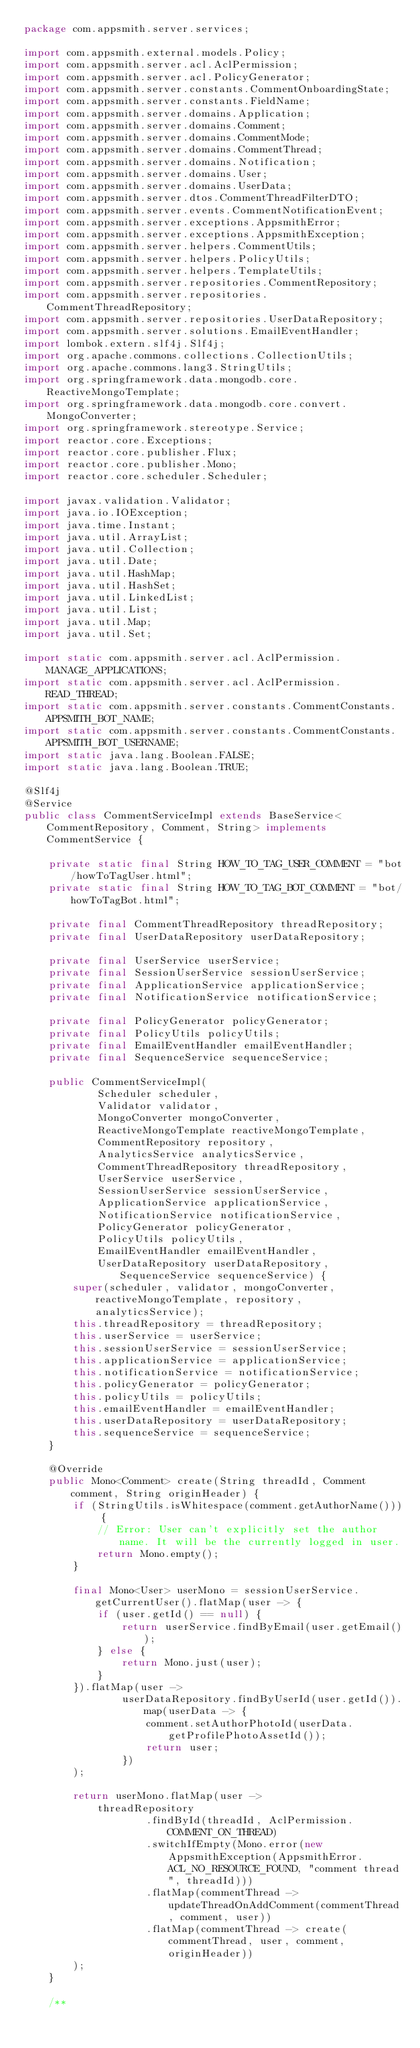Convert code to text. <code><loc_0><loc_0><loc_500><loc_500><_Java_>package com.appsmith.server.services;

import com.appsmith.external.models.Policy;
import com.appsmith.server.acl.AclPermission;
import com.appsmith.server.acl.PolicyGenerator;
import com.appsmith.server.constants.CommentOnboardingState;
import com.appsmith.server.constants.FieldName;
import com.appsmith.server.domains.Application;
import com.appsmith.server.domains.Comment;
import com.appsmith.server.domains.CommentMode;
import com.appsmith.server.domains.CommentThread;
import com.appsmith.server.domains.Notification;
import com.appsmith.server.domains.User;
import com.appsmith.server.domains.UserData;
import com.appsmith.server.dtos.CommentThreadFilterDTO;
import com.appsmith.server.events.CommentNotificationEvent;
import com.appsmith.server.exceptions.AppsmithError;
import com.appsmith.server.exceptions.AppsmithException;
import com.appsmith.server.helpers.CommentUtils;
import com.appsmith.server.helpers.PolicyUtils;
import com.appsmith.server.helpers.TemplateUtils;
import com.appsmith.server.repositories.CommentRepository;
import com.appsmith.server.repositories.CommentThreadRepository;
import com.appsmith.server.repositories.UserDataRepository;
import com.appsmith.server.solutions.EmailEventHandler;
import lombok.extern.slf4j.Slf4j;
import org.apache.commons.collections.CollectionUtils;
import org.apache.commons.lang3.StringUtils;
import org.springframework.data.mongodb.core.ReactiveMongoTemplate;
import org.springframework.data.mongodb.core.convert.MongoConverter;
import org.springframework.stereotype.Service;
import reactor.core.Exceptions;
import reactor.core.publisher.Flux;
import reactor.core.publisher.Mono;
import reactor.core.scheduler.Scheduler;

import javax.validation.Validator;
import java.io.IOException;
import java.time.Instant;
import java.util.ArrayList;
import java.util.Collection;
import java.util.Date;
import java.util.HashMap;
import java.util.HashSet;
import java.util.LinkedList;
import java.util.List;
import java.util.Map;
import java.util.Set;

import static com.appsmith.server.acl.AclPermission.MANAGE_APPLICATIONS;
import static com.appsmith.server.acl.AclPermission.READ_THREAD;
import static com.appsmith.server.constants.CommentConstants.APPSMITH_BOT_NAME;
import static com.appsmith.server.constants.CommentConstants.APPSMITH_BOT_USERNAME;
import static java.lang.Boolean.FALSE;
import static java.lang.Boolean.TRUE;

@Slf4j
@Service
public class CommentServiceImpl extends BaseService<CommentRepository, Comment, String> implements CommentService {

    private static final String HOW_TO_TAG_USER_COMMENT = "bot/howToTagUser.html";
    private static final String HOW_TO_TAG_BOT_COMMENT = "bot/howToTagBot.html";

    private final CommentThreadRepository threadRepository;
    private final UserDataRepository userDataRepository;

    private final UserService userService;
    private final SessionUserService sessionUserService;
    private final ApplicationService applicationService;
    private final NotificationService notificationService;

    private final PolicyGenerator policyGenerator;
    private final PolicyUtils policyUtils;
    private final EmailEventHandler emailEventHandler;
    private final SequenceService sequenceService;

    public CommentServiceImpl(
            Scheduler scheduler,
            Validator validator,
            MongoConverter mongoConverter,
            ReactiveMongoTemplate reactiveMongoTemplate,
            CommentRepository repository,
            AnalyticsService analyticsService,
            CommentThreadRepository threadRepository,
            UserService userService,
            SessionUserService sessionUserService,
            ApplicationService applicationService,
            NotificationService notificationService,
            PolicyGenerator policyGenerator,
            PolicyUtils policyUtils,
            EmailEventHandler emailEventHandler,
            UserDataRepository userDataRepository, SequenceService sequenceService) {
        super(scheduler, validator, mongoConverter, reactiveMongoTemplate, repository, analyticsService);
        this.threadRepository = threadRepository;
        this.userService = userService;
        this.sessionUserService = sessionUserService;
        this.applicationService = applicationService;
        this.notificationService = notificationService;
        this.policyGenerator = policyGenerator;
        this.policyUtils = policyUtils;
        this.emailEventHandler = emailEventHandler;
        this.userDataRepository = userDataRepository;
        this.sequenceService = sequenceService;
    }

    @Override
    public Mono<Comment> create(String threadId, Comment comment, String originHeader) {
        if (StringUtils.isWhitespace(comment.getAuthorName())) {
            // Error: User can't explicitly set the author name. It will be the currently logged in user.
            return Mono.empty();
        }

        final Mono<User> userMono = sessionUserService.getCurrentUser().flatMap(user -> {
            if (user.getId() == null) {
                return userService.findByEmail(user.getEmail());
            } else {
                return Mono.just(user);
            }
        }).flatMap(user ->
                userDataRepository.findByUserId(user.getId()).map(userData -> {
                    comment.setAuthorPhotoId(userData.getProfilePhotoAssetId());
                    return user;
                })
        );

        return userMono.flatMap(user ->
            threadRepository
                    .findById(threadId, AclPermission.COMMENT_ON_THREAD)
                    .switchIfEmpty(Mono.error(new AppsmithException(AppsmithError.ACL_NO_RESOURCE_FOUND, "comment thread", threadId)))
                    .flatMap(commentThread -> updateThreadOnAddComment(commentThread, comment, user))
                    .flatMap(commentThread -> create(commentThread, user, comment, originHeader))
        );
    }

    /**</code> 